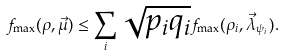<formula> <loc_0><loc_0><loc_500><loc_500>f _ { \max } ( \rho , \vec { \mu } ) \leq \sum _ { i } \sqrt { p _ { i } q _ { i } } f _ { \max } ( \rho _ { i } , \vec { \lambda } _ { \psi _ { i } } ) .</formula> 